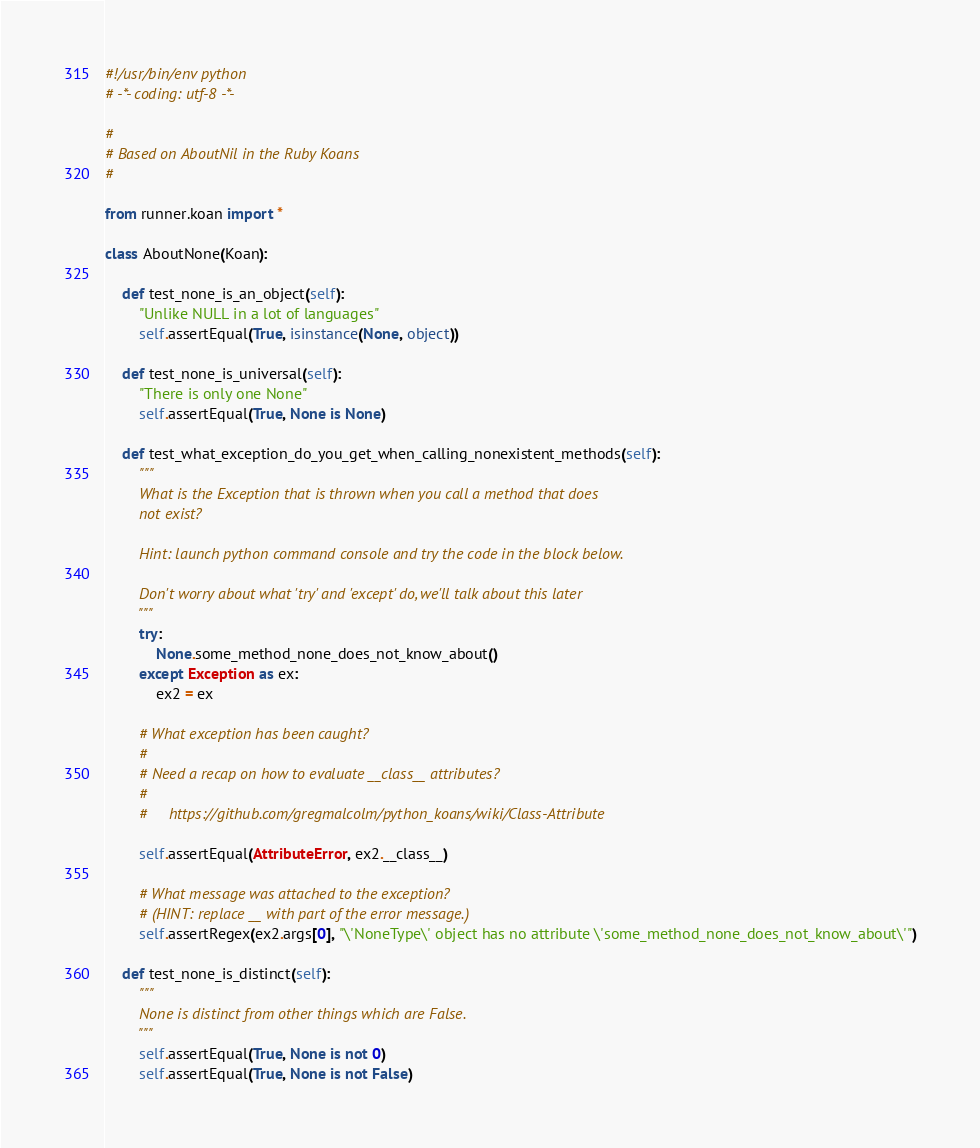<code> <loc_0><loc_0><loc_500><loc_500><_Python_>#!/usr/bin/env python
# -*- coding: utf-8 -*-

#
# Based on AboutNil in the Ruby Koans
#

from runner.koan import *

class AboutNone(Koan):

    def test_none_is_an_object(self):
        "Unlike NULL in a lot of languages"
        self.assertEqual(True, isinstance(None, object))

    def test_none_is_universal(self):
        "There is only one None"
        self.assertEqual(True, None is None)

    def test_what_exception_do_you_get_when_calling_nonexistent_methods(self):
        """
        What is the Exception that is thrown when you call a method that does
        not exist?

        Hint: launch python command console and try the code in the block below.

        Don't worry about what 'try' and 'except' do, we'll talk about this later
        """
        try:
            None.some_method_none_does_not_know_about()
        except Exception as ex:
            ex2 = ex

        # What exception has been caught?
        #
        # Need a recap on how to evaluate __class__ attributes?
        #
        #     https://github.com/gregmalcolm/python_koans/wiki/Class-Attribute

        self.assertEqual(AttributeError, ex2.__class__)

        # What message was attached to the exception?
        # (HINT: replace __ with part of the error message.)
        self.assertRegex(ex2.args[0], "\'NoneType\' object has no attribute \'some_method_none_does_not_know_about\'")

    def test_none_is_distinct(self):
        """
        None is distinct from other things which are False.
        """
        self.assertEqual(True, None is not 0)
        self.assertEqual(True, None is not False)
</code> 